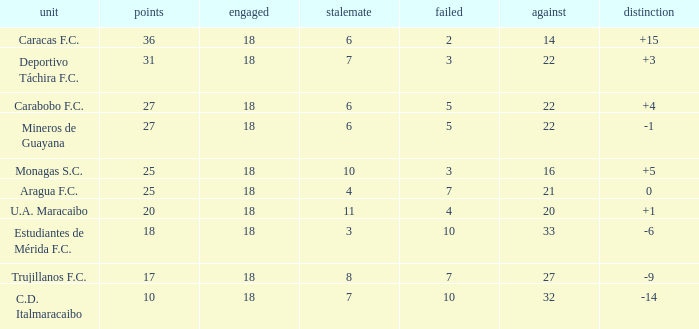Would you mind parsing the complete table? {'header': ['unit', 'points', 'engaged', 'stalemate', 'failed', 'against', 'distinction'], 'rows': [['Caracas F.C.', '36', '18', '6', '2', '14', '+15'], ['Deportivo Táchira F.C.', '31', '18', '7', '3', '22', '+3'], ['Carabobo F.C.', '27', '18', '6', '5', '22', '+4'], ['Mineros de Guayana', '27', '18', '6', '5', '22', '-1'], ['Monagas S.C.', '25', '18', '10', '3', '16', '+5'], ['Aragua F.C.', '25', '18', '4', '7', '21', '0'], ['U.A. Maracaibo', '20', '18', '11', '4', '20', '+1'], ['Estudiantes de Mérida F.C.', '18', '18', '3', '10', '33', '-6'], ['Trujillanos F.C.', '17', '18', '8', '7', '27', '-9'], ['C.D. Italmaracaibo', '10', '18', '7', '10', '32', '-14']]} What is the lowest number of points of any team with less than 6 draws and less than 18 matches played? None. 